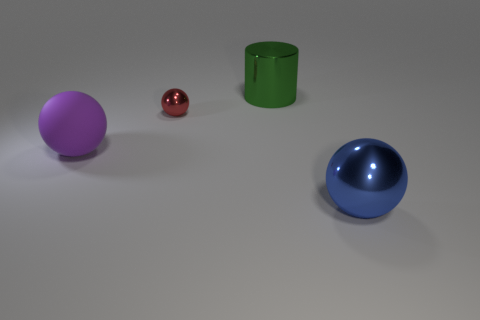There is a thing behind the small metal object; is its color the same as the tiny object?
Offer a very short reply. No. There is a big object to the right of the big thing that is behind the tiny sphere; what shape is it?
Your answer should be compact. Sphere. Is there a cyan block of the same size as the blue thing?
Your response must be concise. No. Is the number of big blue things less than the number of large cyan rubber blocks?
Your answer should be very brief. No. There is a object in front of the large object to the left of the big metal thing that is behind the large purple thing; what shape is it?
Your answer should be very brief. Sphere. How many objects are balls right of the purple rubber object or metallic balls that are in front of the big rubber sphere?
Your response must be concise. 2. There is a metal cylinder; are there any small red shiny spheres behind it?
Keep it short and to the point. No. What number of things are big things that are right of the big shiny cylinder or small spheres?
Provide a succinct answer. 2. What number of brown objects are large cylinders or rubber spheres?
Make the answer very short. 0. What number of other objects are there of the same color as the rubber object?
Offer a very short reply. 0. 